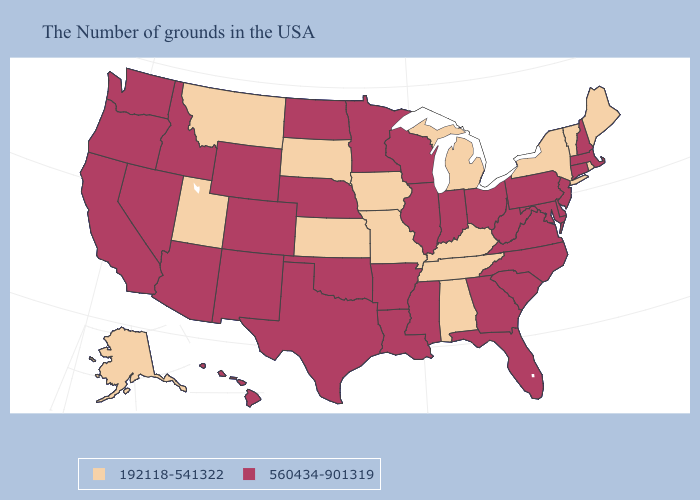Does the map have missing data?
Concise answer only. No. What is the value of Minnesota?
Short answer required. 560434-901319. Name the states that have a value in the range 192118-541322?
Write a very short answer. Maine, Rhode Island, Vermont, New York, Michigan, Kentucky, Alabama, Tennessee, Missouri, Iowa, Kansas, South Dakota, Utah, Montana, Alaska. Which states hav the highest value in the South?
Write a very short answer. Delaware, Maryland, Virginia, North Carolina, South Carolina, West Virginia, Florida, Georgia, Mississippi, Louisiana, Arkansas, Oklahoma, Texas. Which states have the highest value in the USA?
Keep it brief. Massachusetts, New Hampshire, Connecticut, New Jersey, Delaware, Maryland, Pennsylvania, Virginia, North Carolina, South Carolina, West Virginia, Ohio, Florida, Georgia, Indiana, Wisconsin, Illinois, Mississippi, Louisiana, Arkansas, Minnesota, Nebraska, Oklahoma, Texas, North Dakota, Wyoming, Colorado, New Mexico, Arizona, Idaho, Nevada, California, Washington, Oregon, Hawaii. How many symbols are there in the legend?
Short answer required. 2. Among the states that border Illinois , does Missouri have the highest value?
Short answer required. No. Which states have the lowest value in the West?
Give a very brief answer. Utah, Montana, Alaska. What is the value of New Hampshire?
Keep it brief. 560434-901319. What is the lowest value in the Northeast?
Answer briefly. 192118-541322. What is the highest value in the Northeast ?
Answer briefly. 560434-901319. How many symbols are there in the legend?
Answer briefly. 2. Which states have the lowest value in the USA?
Keep it brief. Maine, Rhode Island, Vermont, New York, Michigan, Kentucky, Alabama, Tennessee, Missouri, Iowa, Kansas, South Dakota, Utah, Montana, Alaska. Does the map have missing data?
Answer briefly. No. Is the legend a continuous bar?
Answer briefly. No. 